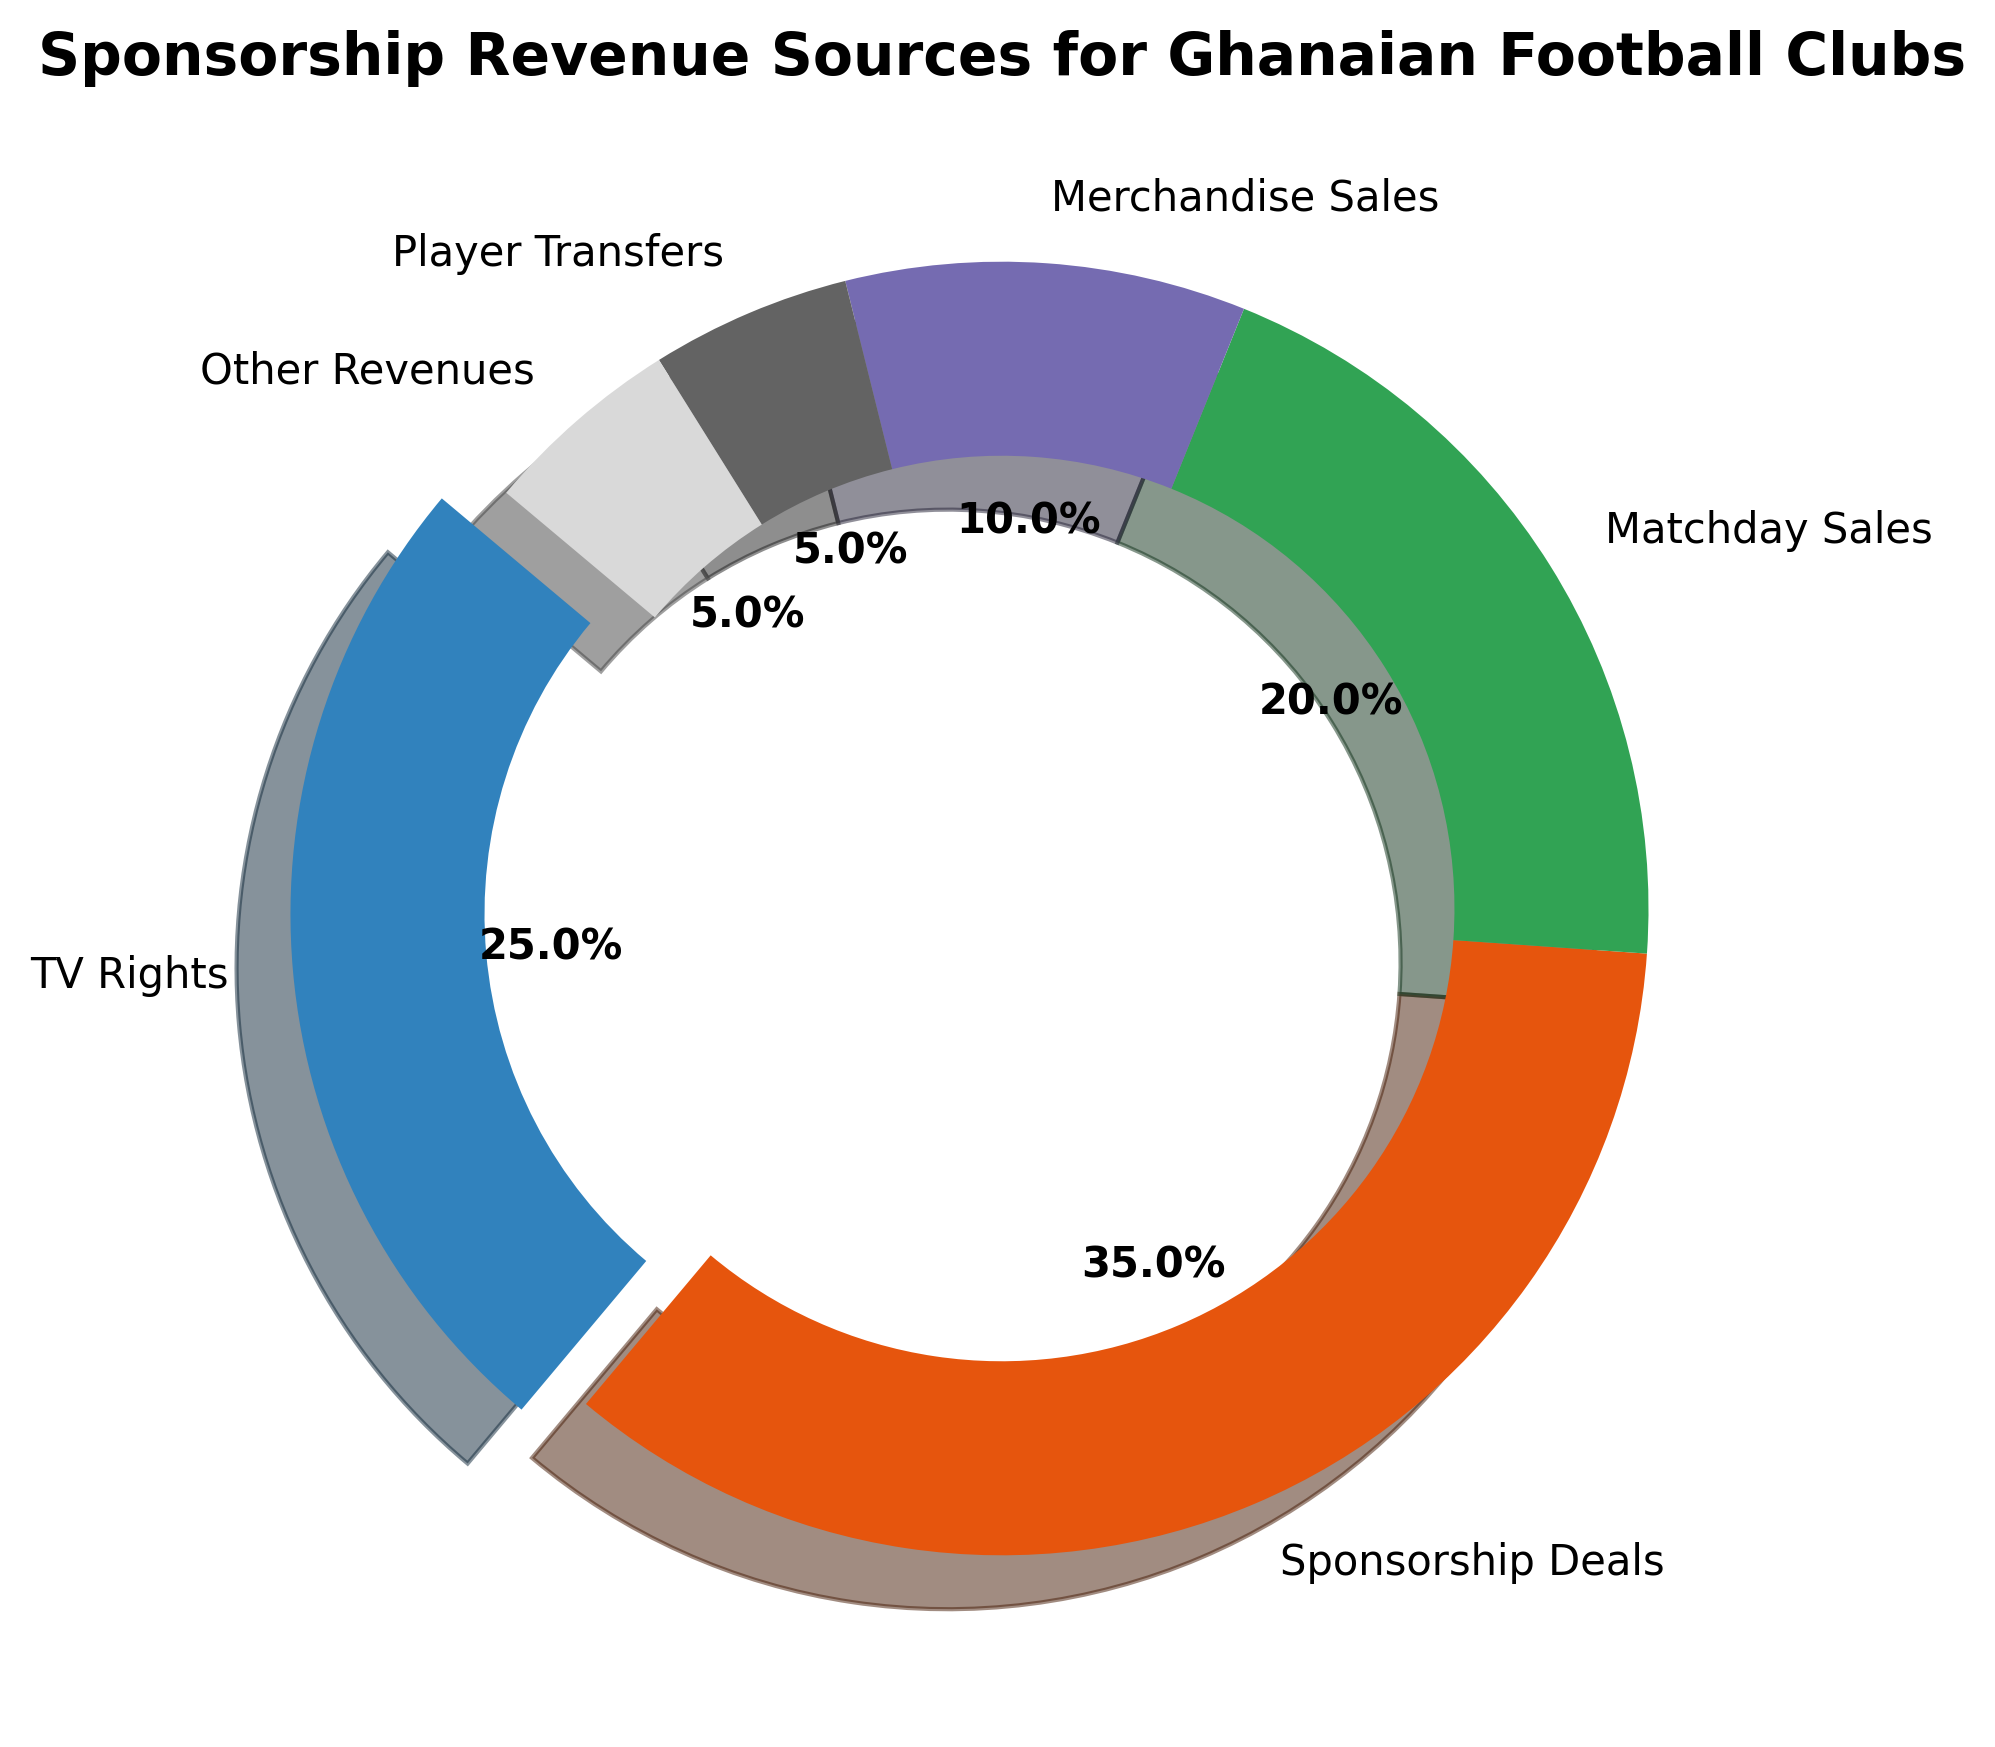What category is the largest source of sponsorship revenue? The pie chart clearly shows that "Sponsorship Deals" occupies the largest portion of the pie. By visually comparing the sizes of the slices, it is evident that "Sponsorship Deals" is the largest.
Answer: Sponsorship Deals How much larger is the Sponsorship Deals slice compared to the Matchday Sales slice? "Sponsorship Deals" contributes 35% and "Matchday Sales" contributes 20% of the total revenue. To find the difference, subtract 20% from 35% (35% - 20%).
Answer: 15% What total percentage is contributed by TV Rights, Matchday Sales, and Merchandise Sales combined? Add up the percentages for TV Rights (25%), Matchday Sales (20%), and Merchandise Sales (10%). The sum is 25% + 20% + 10%.
Answer: 55% Which category is represented with an exploded slice in the pie chart? The pie chart visually emphasizes the "TV Rights" category by separating, or "exploding," its slice from the rest of the chart. This highlights its significance.
Answer: TV Rights How do the contributions of TV Rights and Player Transfers compare? The contribution of "TV Rights" is 25%, while "Player Transfers" contributes 5%. By comparing these percentages, we see that TV Rights is substantially larger.
Answer: TV Rights is larger What portion of the pie chart does the "Other Revenues" category occupy? The pie chart shows that "Other Revenues" comprises 5% of the total sponsorship revenue, as indicated by its corresponding slice.
Answer: 5% Are Matchday Sales and Merchandise Sales combined larger than TV Rights? The percentages for Matchday Sales and Merchandise Sales combined are (20% + 10%) = 30%. Comparing this to TV Rights, which is 25%, shows that the combined value is larger.
Answer: Yes If we exclude the largest revenue source, what is the combined percentage of the remaining categories? Excluding the largest revenue source (Sponsorship Deals at 35%), the remaining percentages are: TV Rights (25%), Matchday Sales (20%), Merchandise Sales (10%), Player Transfers (5%), and Other Revenues (5%). The combined percentage is 25% + 20% + 10% + 5% + 5%.
Answer: 65% Is there a category with the same percentage as "Player Transfers"? By inspecting the pie chart, we see that "Other Revenues" also has a slice representing 5%, which matches the percentage of "Player Transfers".
Answer: Yes Which category contributes the least to the sponsorship revenue? Examining the pie chart, both "Player Transfers" and "Other Revenues" contribute the least, each with a 5% share.
Answer: Player Transfers and Other Revenues 